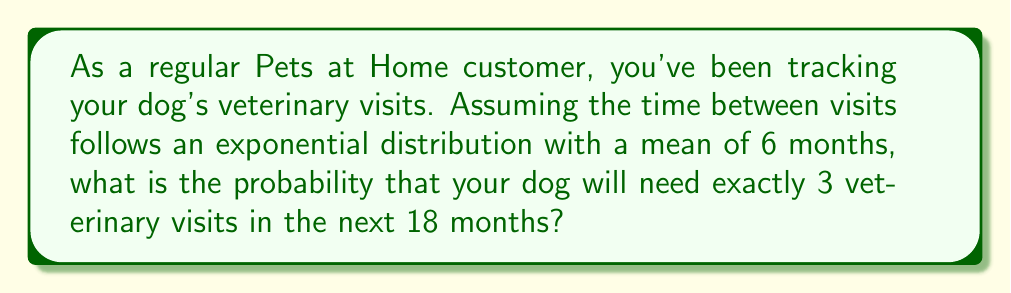Could you help me with this problem? Let's approach this step-by-step using the Poisson process, which is a type of renewal process:

1) The exponential distribution of inter-arrival times with mean 6 months implies that the rate parameter λ of the Poisson process is:

   $$ \lambda = \frac{1}{6} \text{ visits/month} $$

2) For a Poisson process, the number of events in a fixed time interval follows a Poisson distribution. The mean number of events in time t is λt.

3) In this case, t = 18 months, so the mean number of visits in 18 months is:

   $$ \mu = \lambda t = \frac{1}{6} \cdot 18 = 3 \text{ visits} $$

4) The probability of exactly k events in a Poisson process is given by the Poisson probability mass function:

   $$ P(X = k) = \frac{e^{-\mu} \mu^k}{k!} $$

5) We want the probability of exactly 3 visits in 18 months, so k = 3:

   $$ P(X = 3) = \frac{e^{-3} 3^3}{3!} $$

6) Calculating this:

   $$ P(X = 3) = \frac{e^{-3} \cdot 27}{6} \approx 0.2240 $$

Therefore, the probability of exactly 3 veterinary visits in the next 18 months is approximately 0.2240 or 22.40%.
Answer: 0.2240 